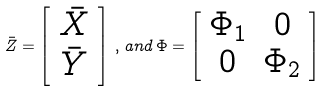<formula> <loc_0><loc_0><loc_500><loc_500>\bar { Z } = \left [ \begin{array} { c } \bar { X } \\ \bar { Y } \end{array} \right ] \, , \, a n d \, \Phi = \left [ \begin{array} { c c } \Phi _ { 1 } & 0 \\ 0 & \Phi _ { 2 } \end{array} \right ]</formula> 